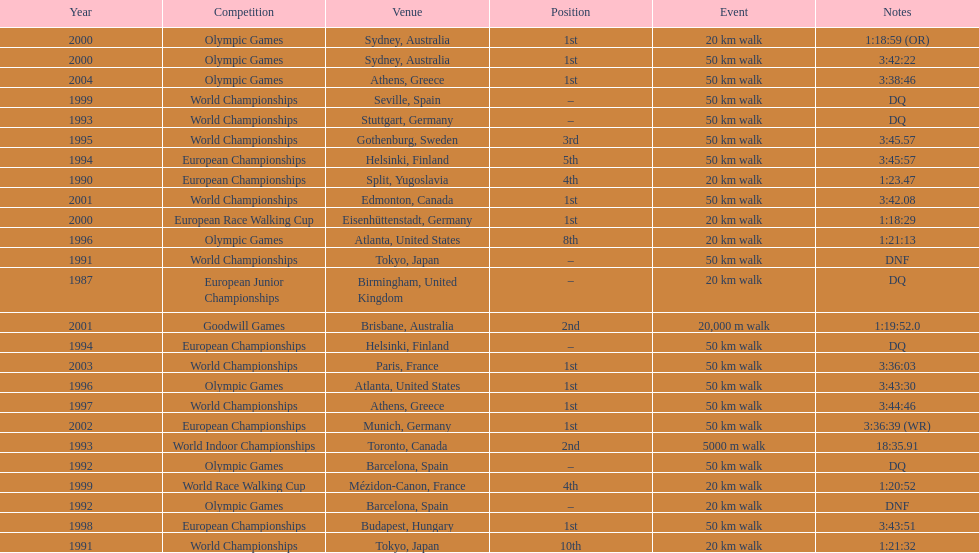How many times was korzeniowski disqualified from a competition? 5. 